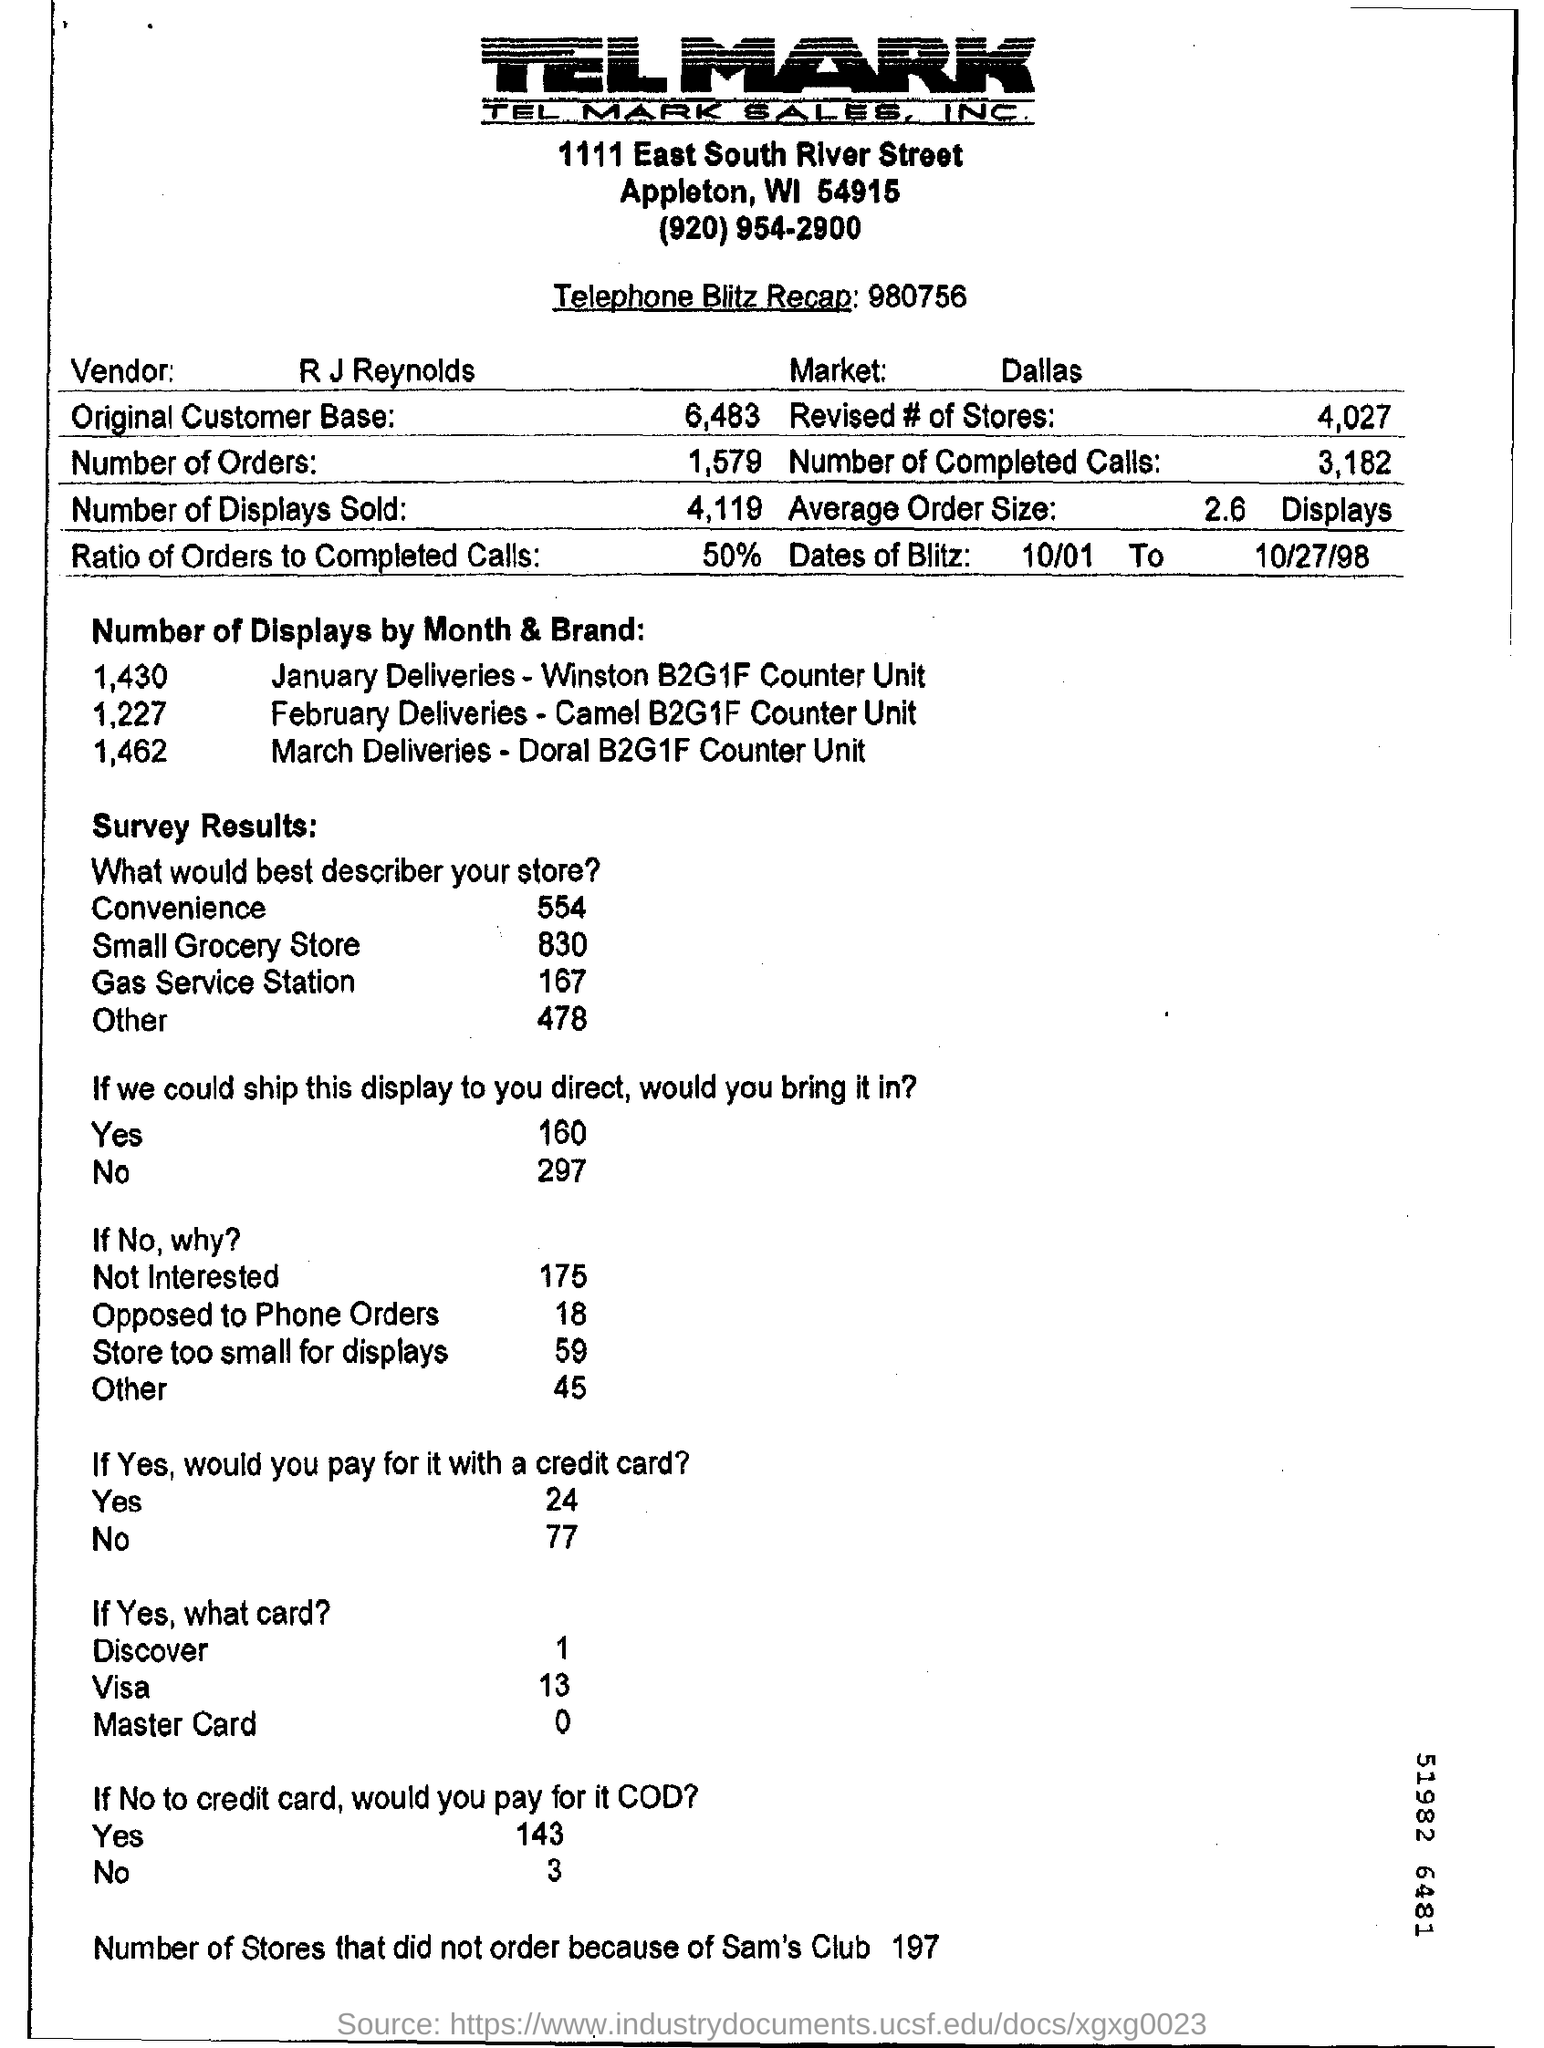What is the name of the vendor?
Give a very brief answer. R J Reynolds. What is the market mentioned on the form?
Your answer should be very brief. Dallas. What are the revised number of stores?
Your response must be concise. 4027. How much is the ratio of orders to completed cells?
Provide a short and direct response. 50%. How many number of stores that did not order because of Sam's club?
Your answer should be compact. 197. Number of displays by month and brand is mentioned for how many months?
Your answer should be compact. 3. 